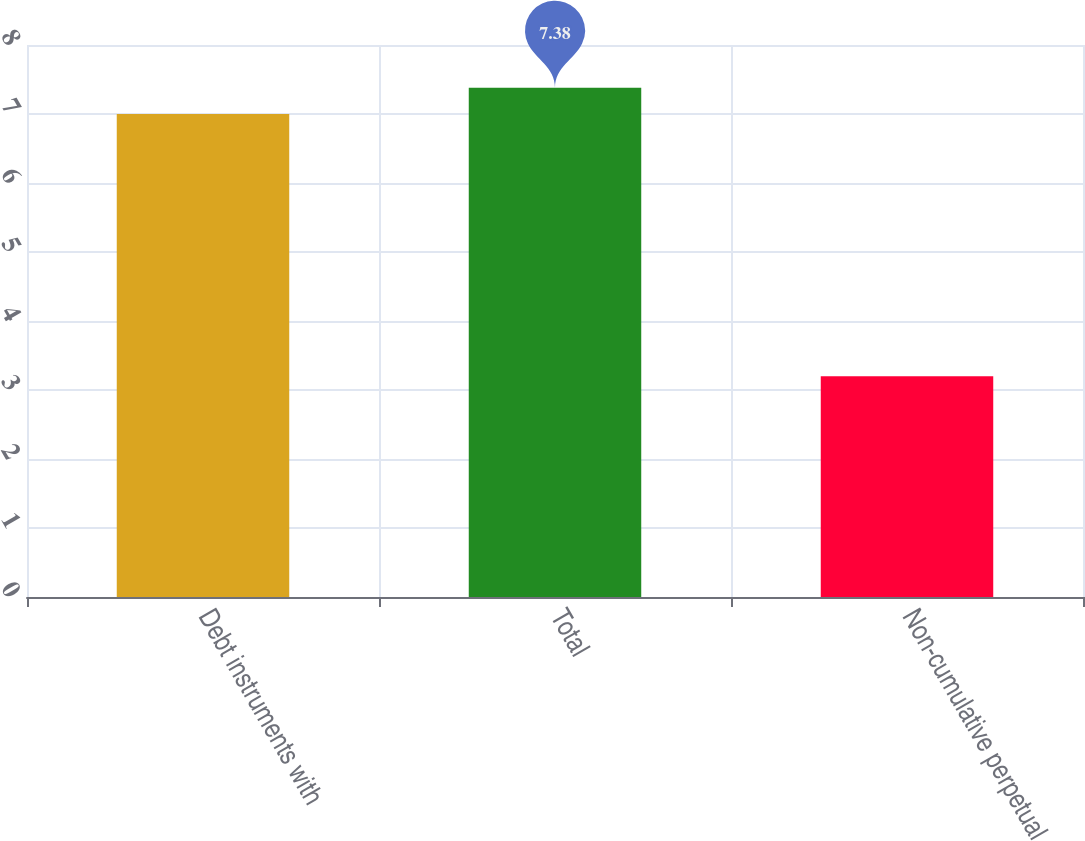<chart> <loc_0><loc_0><loc_500><loc_500><bar_chart><fcel>Debt instruments with<fcel>Total<fcel>Non-cumulative perpetual<nl><fcel>7<fcel>7.38<fcel>3.2<nl></chart> 